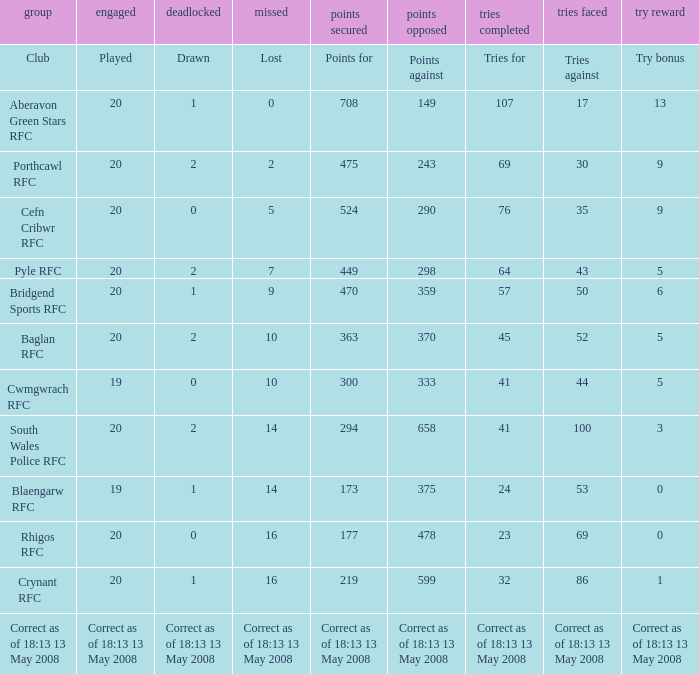What is the points number when 20 shows for played, and lost is 0? 708.0. 